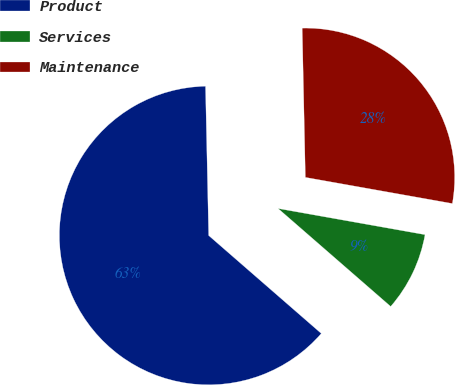Convert chart to OTSL. <chart><loc_0><loc_0><loc_500><loc_500><pie_chart><fcel>Product<fcel>Services<fcel>Maintenance<nl><fcel>63.26%<fcel>8.59%<fcel>28.14%<nl></chart> 